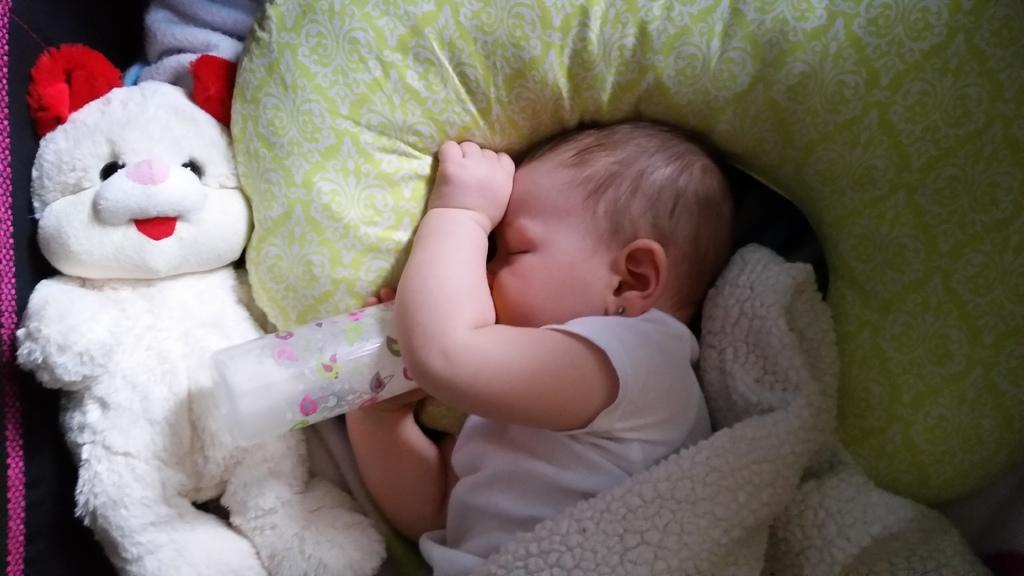What is the main subject of the picture? The main subject of the picture is a kid. What is the kid doing in the picture? The kid is sleeping on a pillow. What is the kid holding in the picture? The kid is holding a bottle. What can be seen on the left side of the picture? There is a doll on the left side of the picture. What is covering the kid in the picture? A bed sheet is visible in the picture. How many cattle are visible in the picture? There are no cattle present in the picture. What type of rose can be seen on the bed sheet? There is no rose visible in the picture, and the bed sheet is not described as having any patterns or designs. 